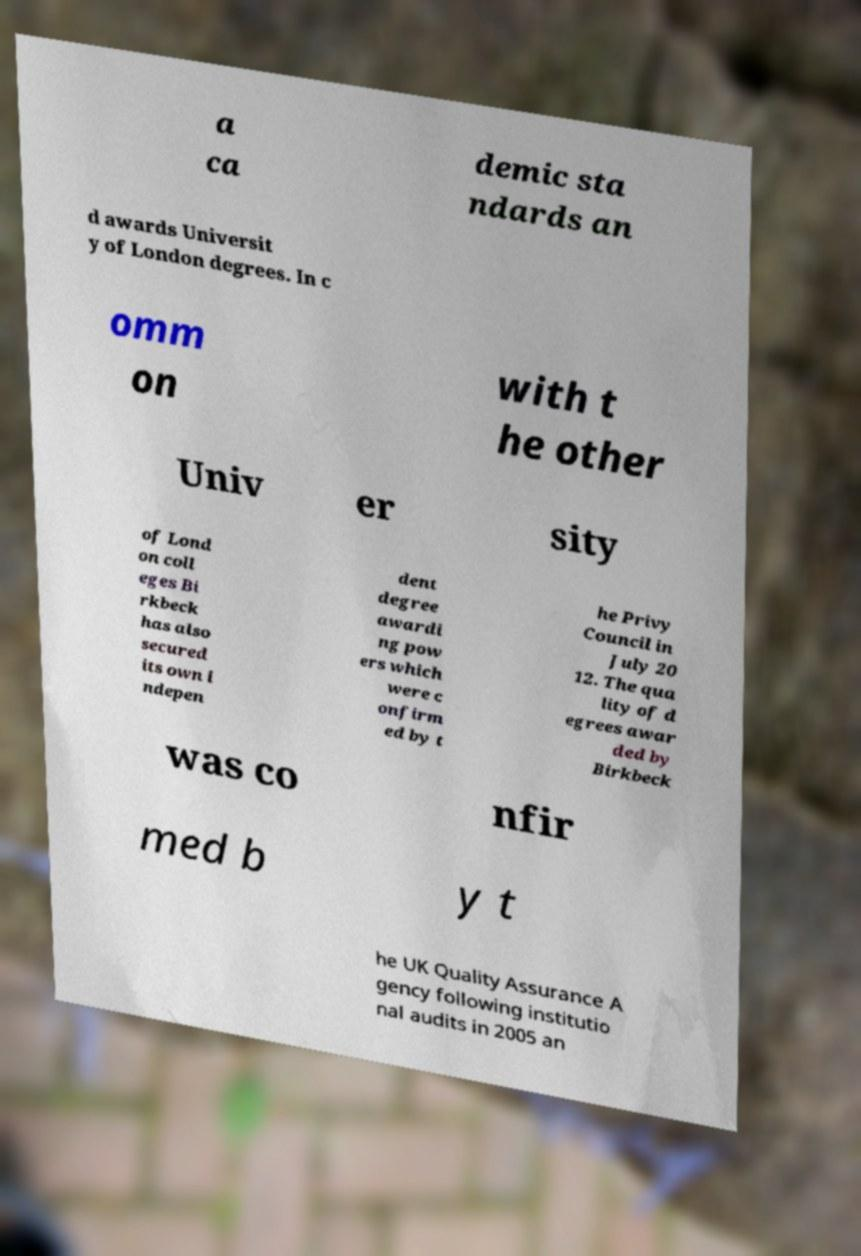There's text embedded in this image that I need extracted. Can you transcribe it verbatim? a ca demic sta ndards an d awards Universit y of London degrees. In c omm on with t he other Univ er sity of Lond on coll eges Bi rkbeck has also secured its own i ndepen dent degree awardi ng pow ers which were c onfirm ed by t he Privy Council in July 20 12. The qua lity of d egrees awar ded by Birkbeck was co nfir med b y t he UK Quality Assurance A gency following institutio nal audits in 2005 an 